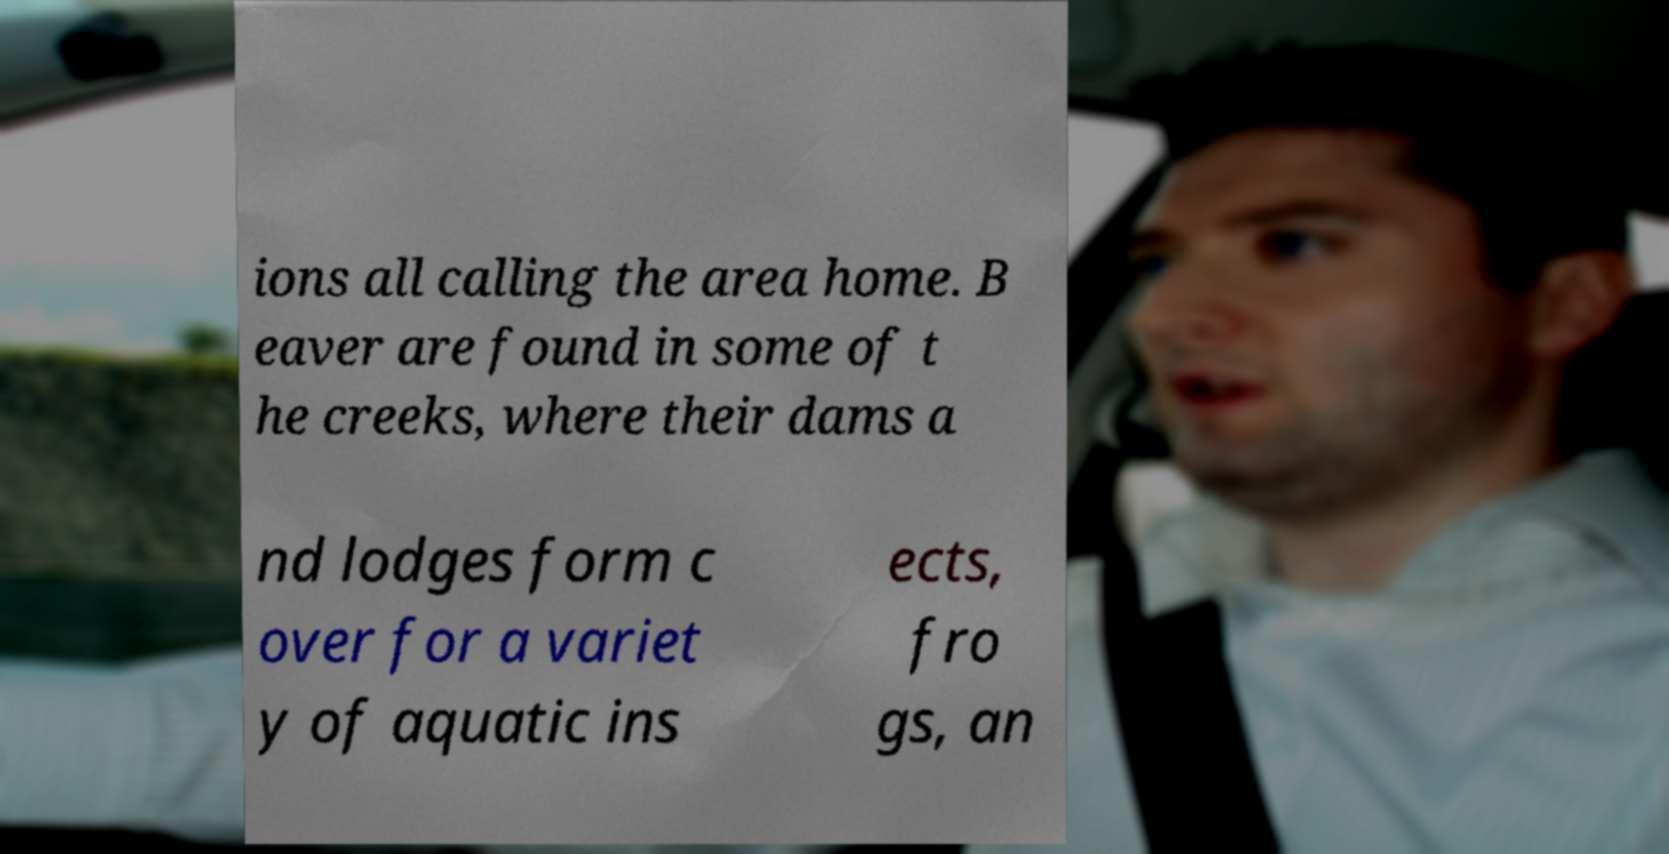What messages or text are displayed in this image? I need them in a readable, typed format. ions all calling the area home. B eaver are found in some of t he creeks, where their dams a nd lodges form c over for a variet y of aquatic ins ects, fro gs, an 